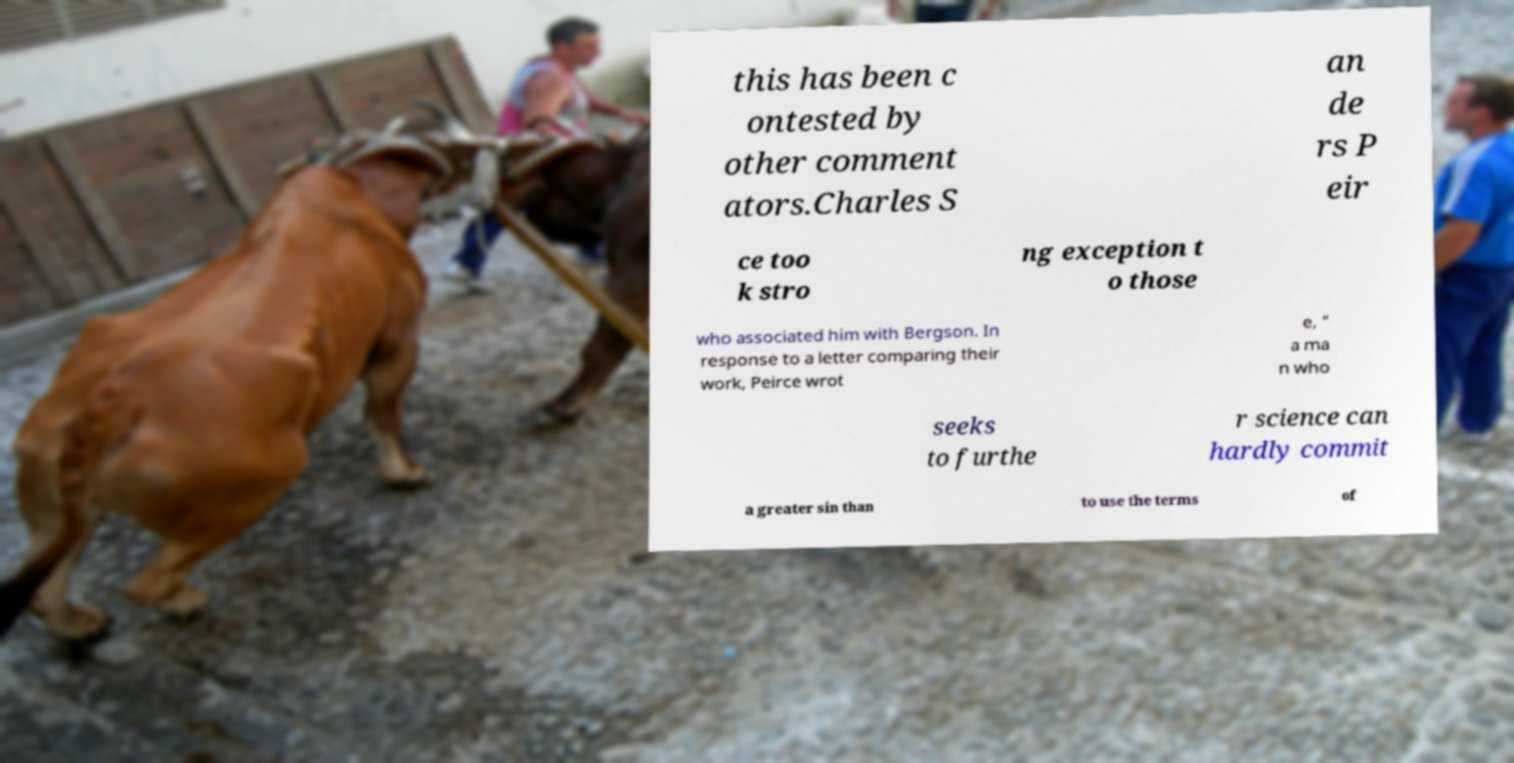Can you read and provide the text displayed in the image?This photo seems to have some interesting text. Can you extract and type it out for me? this has been c ontested by other comment ators.Charles S an de rs P eir ce too k stro ng exception t o those who associated him with Bergson. In response to a letter comparing their work, Peirce wrot e, " a ma n who seeks to furthe r science can hardly commit a greater sin than to use the terms of 